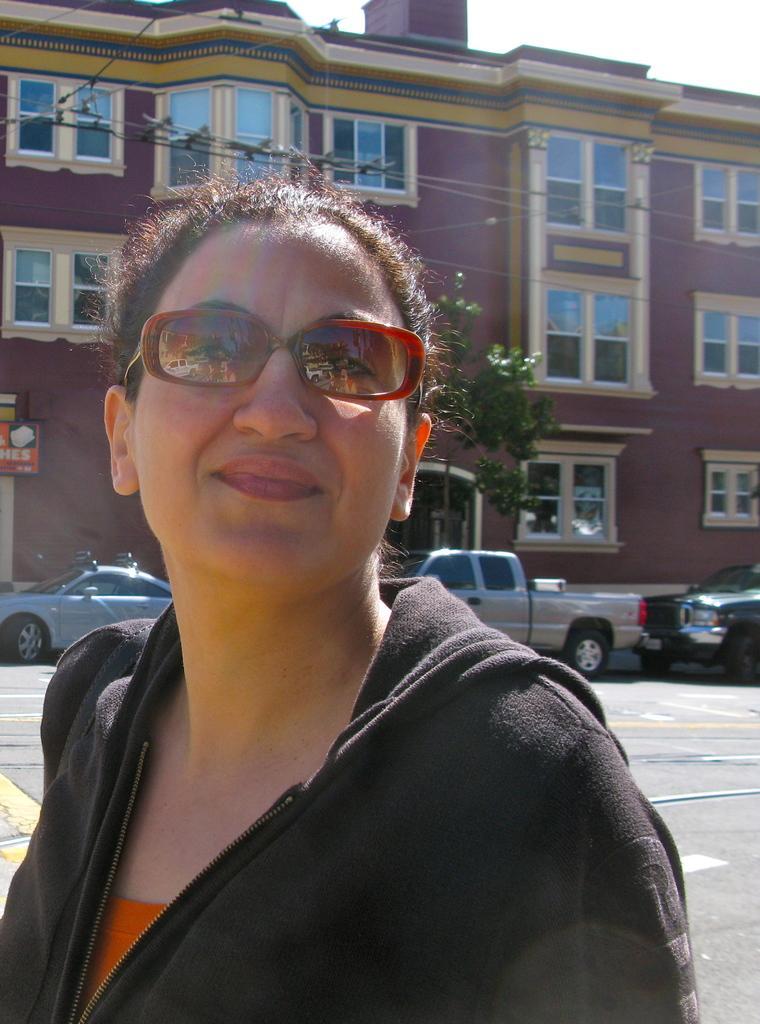How would you summarize this image in a sentence or two? In this image we can see a lady wearing glasses. In the background there is a building and we can see cars. There are wires and there is a tree. At the top there is sky. 